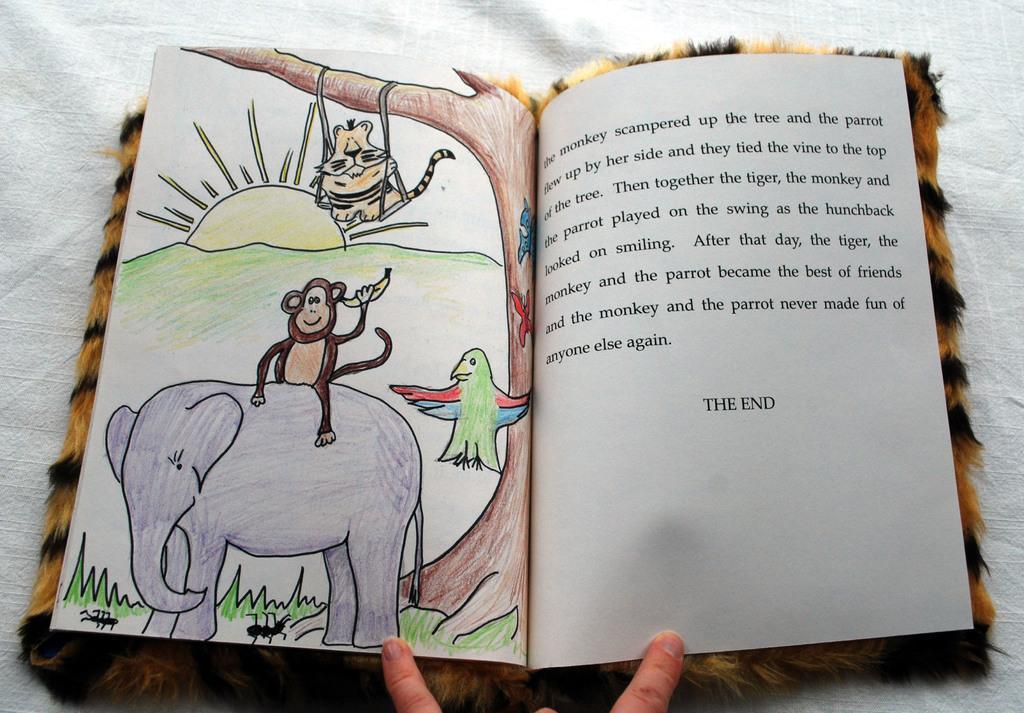Could you give a brief overview of what you see in this image? As we can see in the image there is a book and white color cloth. On book there is some matter written and drawing of an elephant, monkey, bird and sun. 